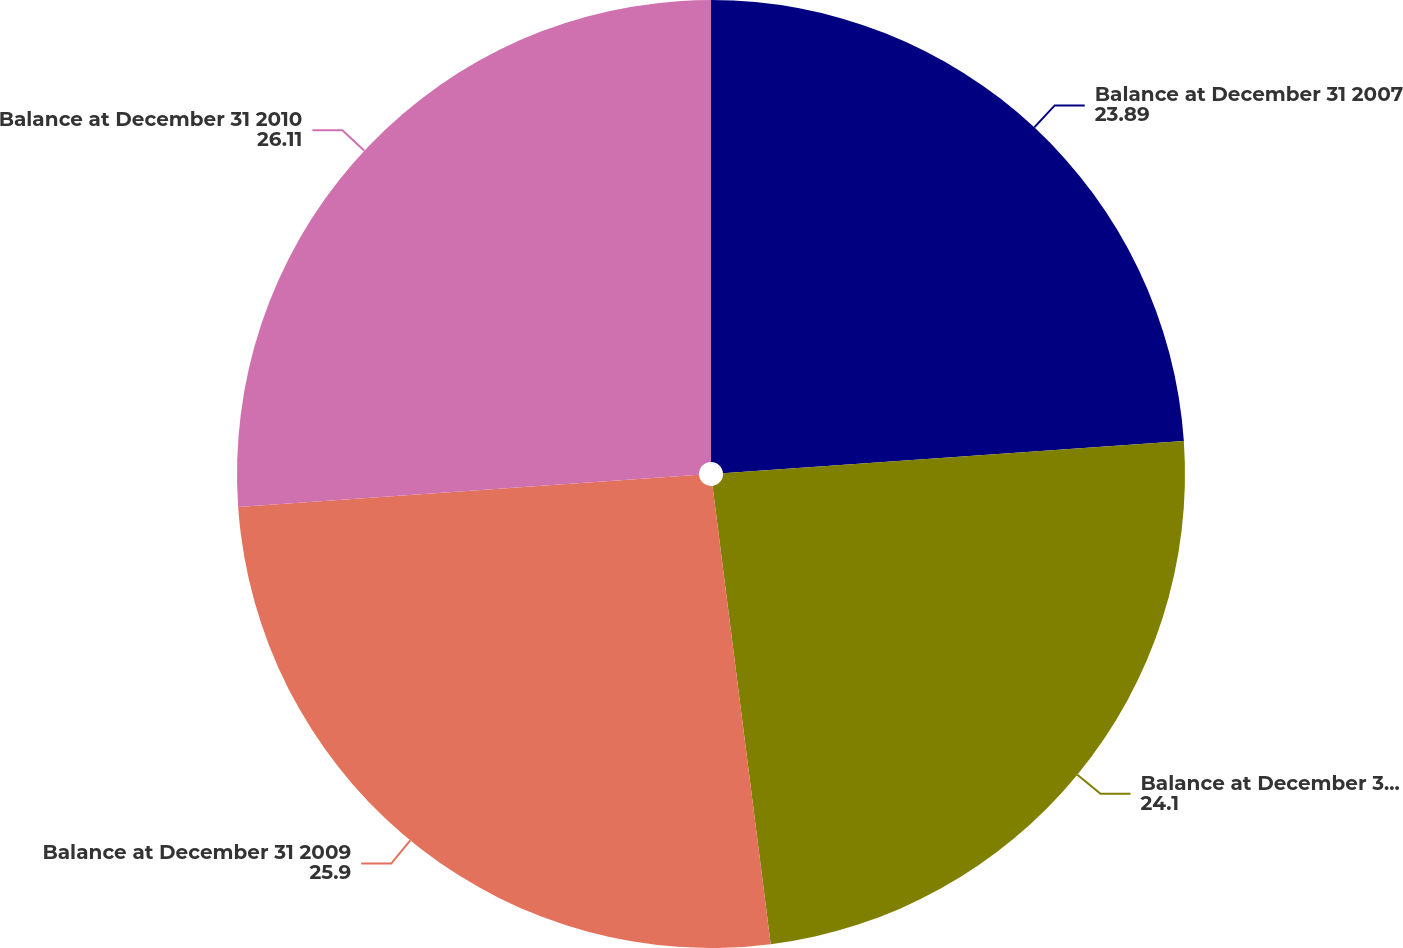Convert chart. <chart><loc_0><loc_0><loc_500><loc_500><pie_chart><fcel>Balance at December 31 2007<fcel>Balance at December 31 2008<fcel>Balance at December 31 2009<fcel>Balance at December 31 2010<nl><fcel>23.89%<fcel>24.1%<fcel>25.9%<fcel>26.11%<nl></chart> 